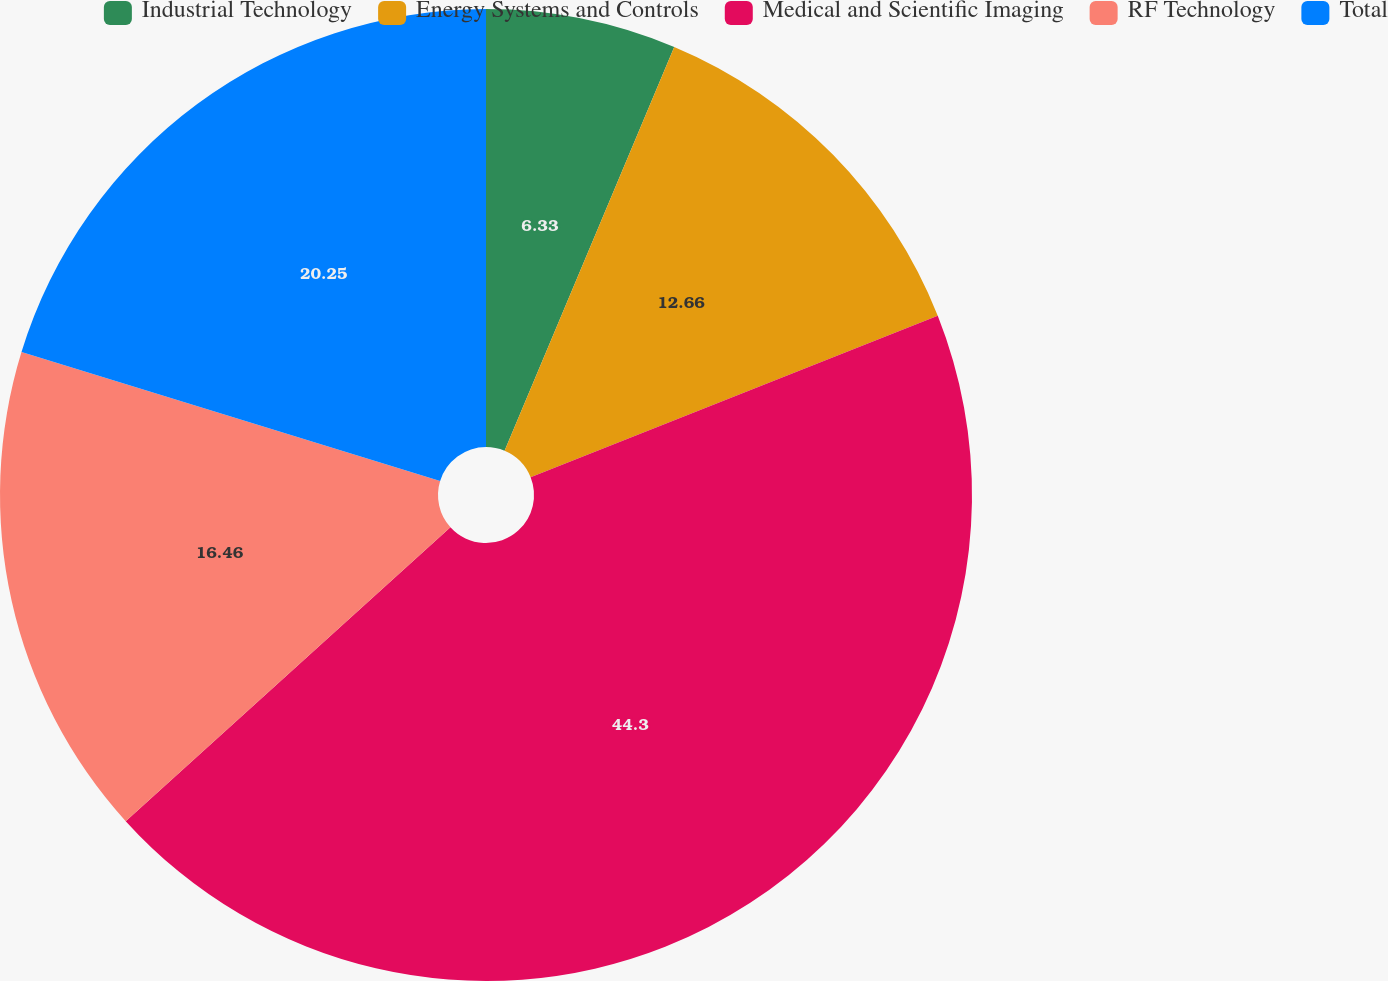Convert chart. <chart><loc_0><loc_0><loc_500><loc_500><pie_chart><fcel>Industrial Technology<fcel>Energy Systems and Controls<fcel>Medical and Scientific Imaging<fcel>RF Technology<fcel>Total<nl><fcel>6.33%<fcel>12.66%<fcel>44.3%<fcel>16.46%<fcel>20.25%<nl></chart> 